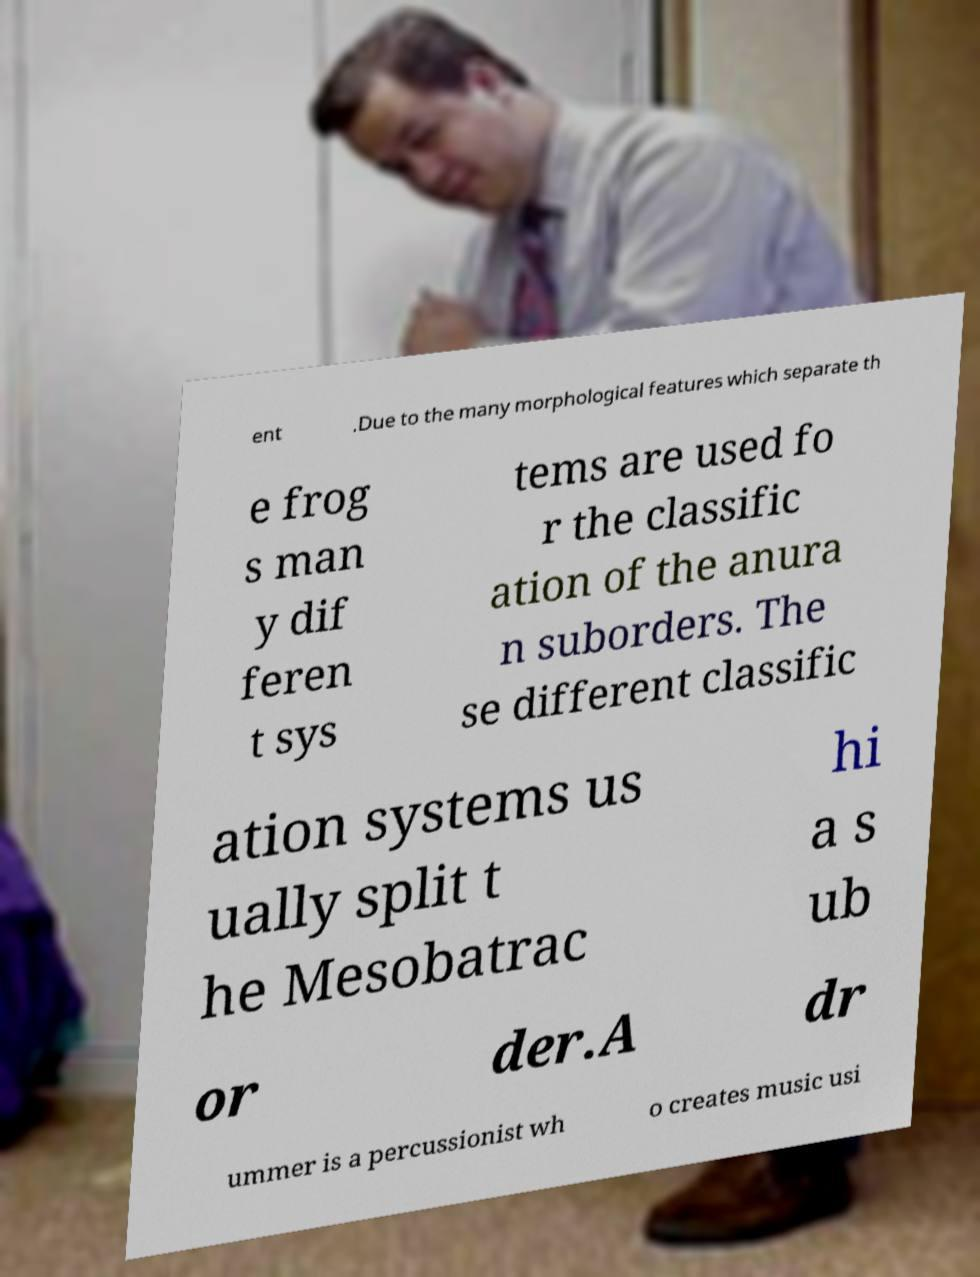Can you accurately transcribe the text from the provided image for me? ent .Due to the many morphological features which separate th e frog s man y dif feren t sys tems are used fo r the classific ation of the anura n suborders. The se different classific ation systems us ually split t he Mesobatrac hi a s ub or der.A dr ummer is a percussionist wh o creates music usi 